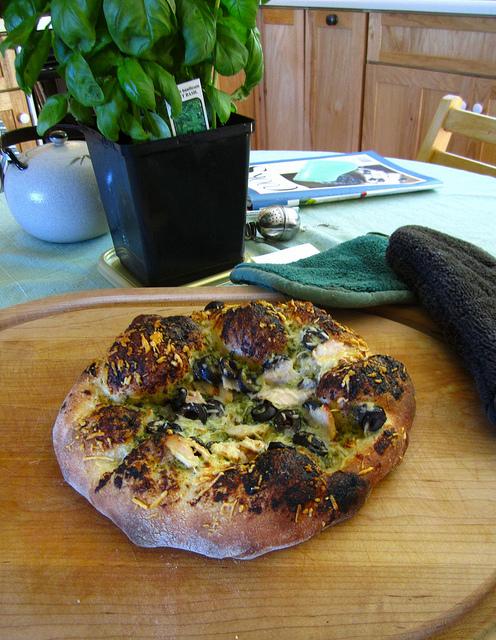Is the plant on the table edible?
Write a very short answer. Yes. Does the plant have flowers?
Keep it brief. No. What color is the plant on the table?
Concise answer only. Green. 